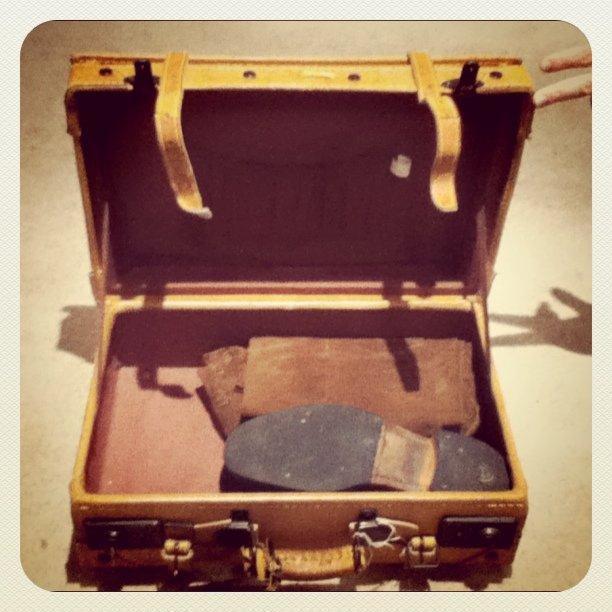How many fingers is the figure holding up next to the suitcase?
Give a very brief answer. 2. How many suitcases are in the photo?
Give a very brief answer. 1. 